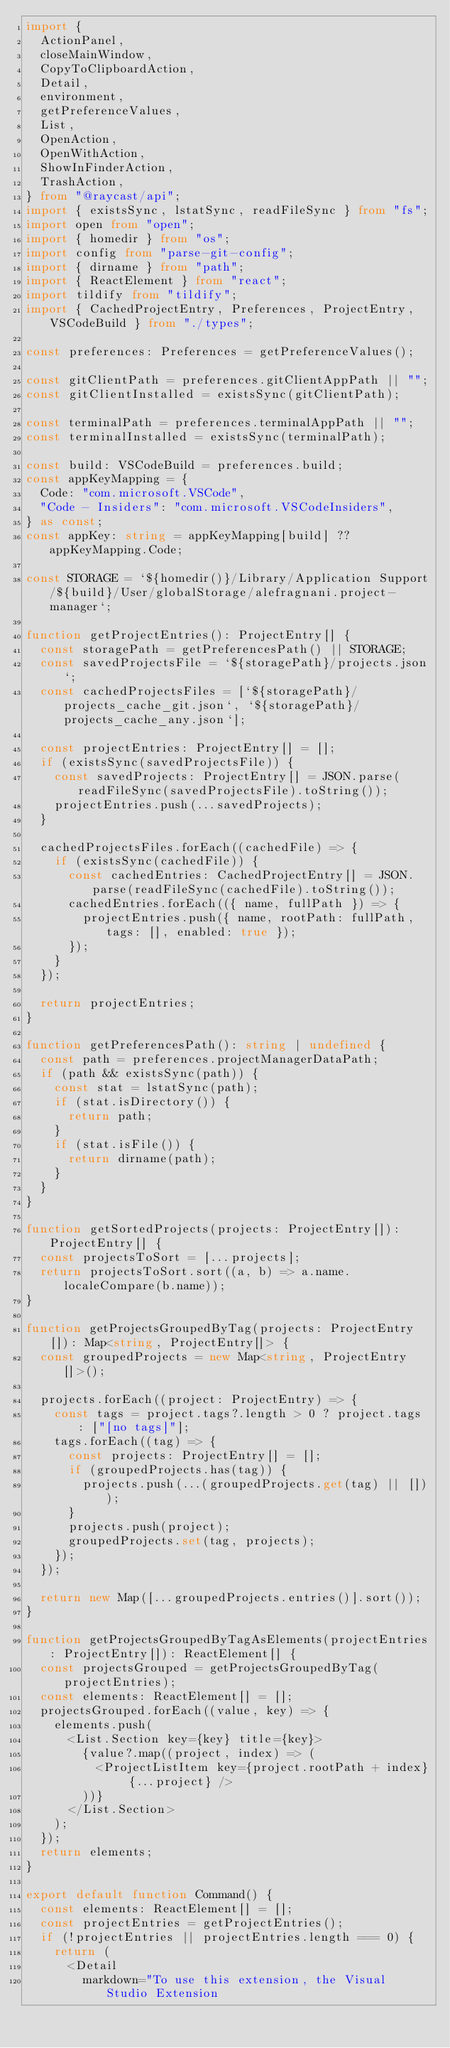Convert code to text. <code><loc_0><loc_0><loc_500><loc_500><_TypeScript_>import {
  ActionPanel,
  closeMainWindow,
  CopyToClipboardAction,
  Detail,
  environment,
  getPreferenceValues,
  List,
  OpenAction,
  OpenWithAction,
  ShowInFinderAction,
  TrashAction,
} from "@raycast/api";
import { existsSync, lstatSync, readFileSync } from "fs";
import open from "open";
import { homedir } from "os";
import config from "parse-git-config";
import { dirname } from "path";
import { ReactElement } from "react";
import tildify from "tildify";
import { CachedProjectEntry, Preferences, ProjectEntry, VSCodeBuild } from "./types";

const preferences: Preferences = getPreferenceValues();

const gitClientPath = preferences.gitClientAppPath || "";
const gitClientInstalled = existsSync(gitClientPath);

const terminalPath = preferences.terminalAppPath || "";
const terminalInstalled = existsSync(terminalPath);

const build: VSCodeBuild = preferences.build;
const appKeyMapping = {
  Code: "com.microsoft.VSCode",
  "Code - Insiders": "com.microsoft.VSCodeInsiders",
} as const;
const appKey: string = appKeyMapping[build] ?? appKeyMapping.Code;

const STORAGE = `${homedir()}/Library/Application Support/${build}/User/globalStorage/alefragnani.project-manager`;

function getProjectEntries(): ProjectEntry[] {
  const storagePath = getPreferencesPath() || STORAGE;
  const savedProjectsFile = `${storagePath}/projects.json`;
  const cachedProjectsFiles = [`${storagePath}/projects_cache_git.json`, `${storagePath}/projects_cache_any.json`];

  const projectEntries: ProjectEntry[] = [];
  if (existsSync(savedProjectsFile)) {
    const savedProjects: ProjectEntry[] = JSON.parse(readFileSync(savedProjectsFile).toString());
    projectEntries.push(...savedProjects);
  }

  cachedProjectsFiles.forEach((cachedFile) => {
    if (existsSync(cachedFile)) {
      const cachedEntries: CachedProjectEntry[] = JSON.parse(readFileSync(cachedFile).toString());
      cachedEntries.forEach(({ name, fullPath }) => {
        projectEntries.push({ name, rootPath: fullPath, tags: [], enabled: true });
      });
    }
  });

  return projectEntries;
}

function getPreferencesPath(): string | undefined {
  const path = preferences.projectManagerDataPath;
  if (path && existsSync(path)) {
    const stat = lstatSync(path);
    if (stat.isDirectory()) {
      return path;
    }
    if (stat.isFile()) {
      return dirname(path);
    }
  }
}

function getSortedProjects(projects: ProjectEntry[]): ProjectEntry[] {
  const projectsToSort = [...projects];
  return projectsToSort.sort((a, b) => a.name.localeCompare(b.name));
}

function getProjectsGroupedByTag(projects: ProjectEntry[]): Map<string, ProjectEntry[]> {
  const groupedProjects = new Map<string, ProjectEntry[]>();

  projects.forEach((project: ProjectEntry) => {
    const tags = project.tags?.length > 0 ? project.tags : ["[no tags]"];
    tags.forEach((tag) => {
      const projects: ProjectEntry[] = [];
      if (groupedProjects.has(tag)) {
        projects.push(...(groupedProjects.get(tag) || []));
      }
      projects.push(project);
      groupedProjects.set(tag, projects);
    });
  });

  return new Map([...groupedProjects.entries()].sort());
}

function getProjectsGroupedByTagAsElements(projectEntries: ProjectEntry[]): ReactElement[] {
  const projectsGrouped = getProjectsGroupedByTag(projectEntries);
  const elements: ReactElement[] = [];
  projectsGrouped.forEach((value, key) => {
    elements.push(
      <List.Section key={key} title={key}>
        {value?.map((project, index) => (
          <ProjectListItem key={project.rootPath + index} {...project} />
        ))}
      </List.Section>
    );
  });
  return elements;
}

export default function Command() {
  const elements: ReactElement[] = [];
  const projectEntries = getProjectEntries();
  if (!projectEntries || projectEntries.length === 0) {
    return (
      <Detail
        markdown="To use this extension, the Visual Studio Extension </code> 